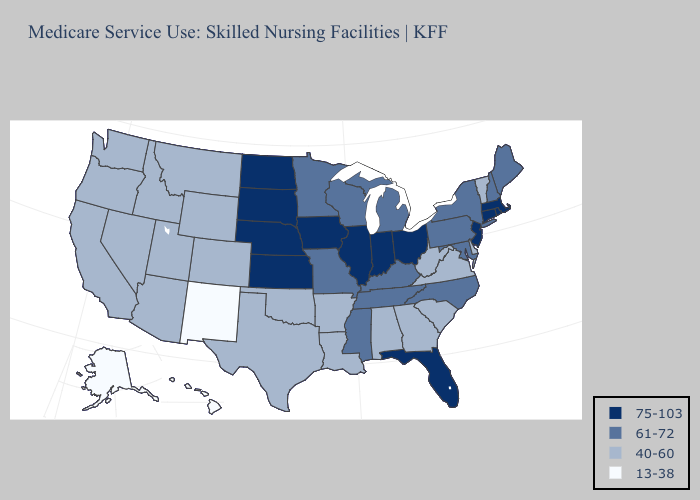Which states hav the highest value in the West?
Be succinct. Arizona, California, Colorado, Idaho, Montana, Nevada, Oregon, Utah, Washington, Wyoming. Name the states that have a value in the range 61-72?
Quick response, please. Kentucky, Maine, Maryland, Michigan, Minnesota, Mississippi, Missouri, New Hampshire, New York, North Carolina, Pennsylvania, Tennessee, Wisconsin. Does North Dakota have the highest value in the USA?
Answer briefly. Yes. What is the highest value in the South ?
Give a very brief answer. 75-103. Does West Virginia have the lowest value in the South?
Short answer required. Yes. Does Kansas have the same value as Idaho?
Be succinct. No. Among the states that border Indiana , does Kentucky have the lowest value?
Keep it brief. Yes. Does Oregon have the highest value in the West?
Short answer required. Yes. Which states have the lowest value in the USA?
Quick response, please. Alaska, Hawaii, New Mexico. Name the states that have a value in the range 13-38?
Short answer required. Alaska, Hawaii, New Mexico. Among the states that border South Carolina , which have the lowest value?
Be succinct. Georgia. Does Montana have a higher value than Arkansas?
Concise answer only. No. How many symbols are there in the legend?
Write a very short answer. 4. What is the lowest value in the West?
Concise answer only. 13-38. What is the highest value in the USA?
Be succinct. 75-103. 